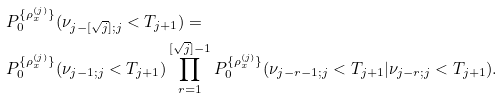Convert formula to latex. <formula><loc_0><loc_0><loc_500><loc_500>& P _ { 0 } ^ { \{ \rho _ { x } ^ { ( j ) } \} } ( \nu _ { j - [ \sqrt { j } ] ; j } < T _ { j + 1 } ) = \\ & P _ { 0 } ^ { \{ \rho _ { x } ^ { ( j ) } \} } ( \nu _ { j - 1 ; j } < T _ { j + 1 } ) \prod _ { r = 1 } ^ { [ \sqrt { j } ] - 1 } P _ { 0 } ^ { \{ \rho _ { x } ^ { ( j ) } \} } ( \nu _ { j - r - 1 ; j } < T _ { j + 1 } | \nu _ { j - r ; j } < T _ { j + 1 } ) .</formula> 